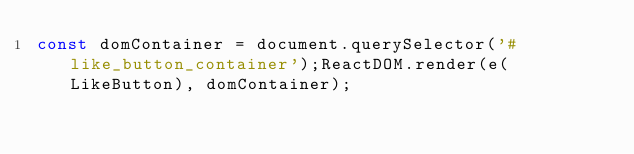<code> <loc_0><loc_0><loc_500><loc_500><_JavaScript_>const domContainer = document.querySelector('#like_button_container');ReactDOM.render(e(LikeButton), domContainer);</code> 